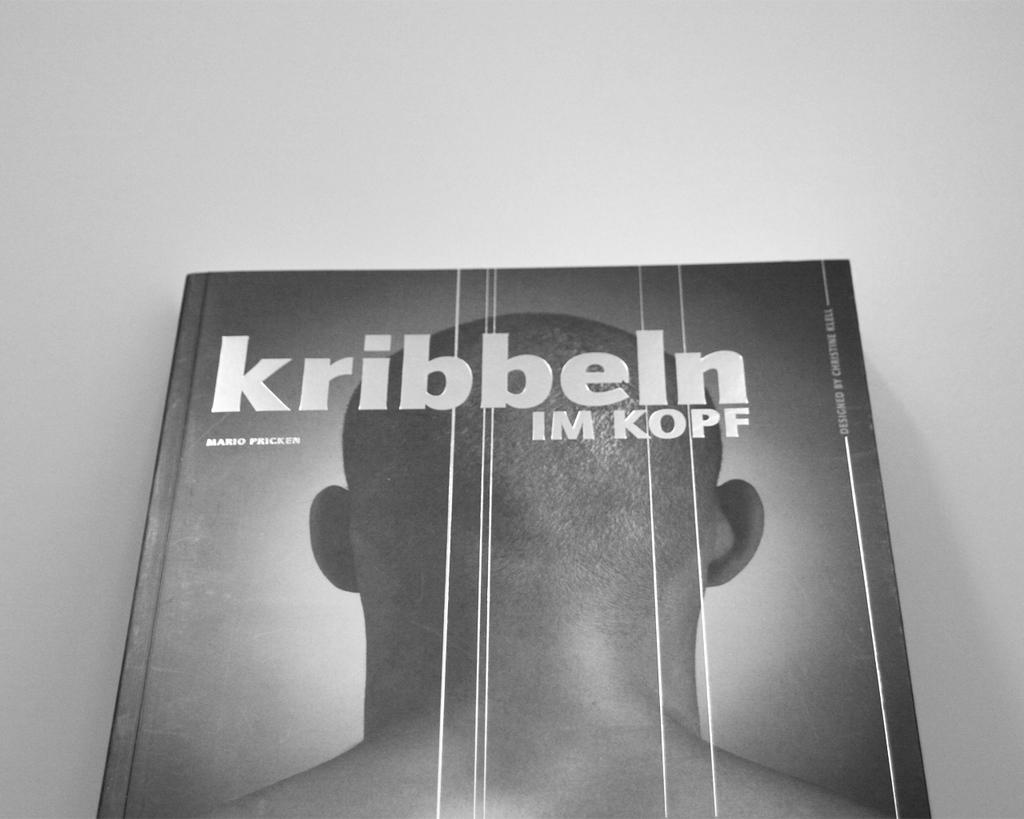<image>
Provide a brief description of the given image. A picture of a man with the words kribbeln IM KOPF is displayed in black and white 